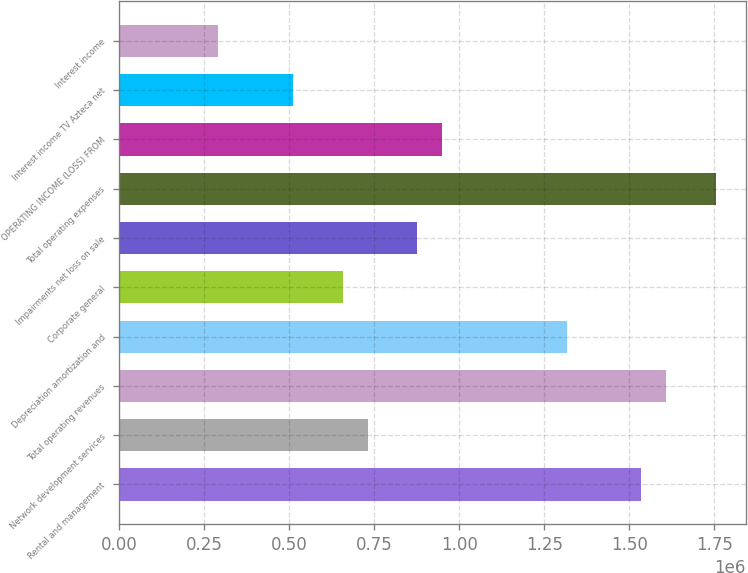Convert chart to OTSL. <chart><loc_0><loc_0><loc_500><loc_500><bar_chart><fcel>Rental and management<fcel>Network development services<fcel>Total operating revenues<fcel>Depreciation amortization and<fcel>Corporate general<fcel>Impairments net loss on sale<fcel>Total operating expenses<fcel>OPERATING INCOME (LOSS) FROM<fcel>Interest income TV Azteca net<fcel>Interest income<nl><fcel>1.53569e+06<fcel>731281<fcel>1.60882e+06<fcel>1.3163e+06<fcel>658153<fcel>877537<fcel>1.75507e+06<fcel>950665<fcel>511897<fcel>292513<nl></chart> 